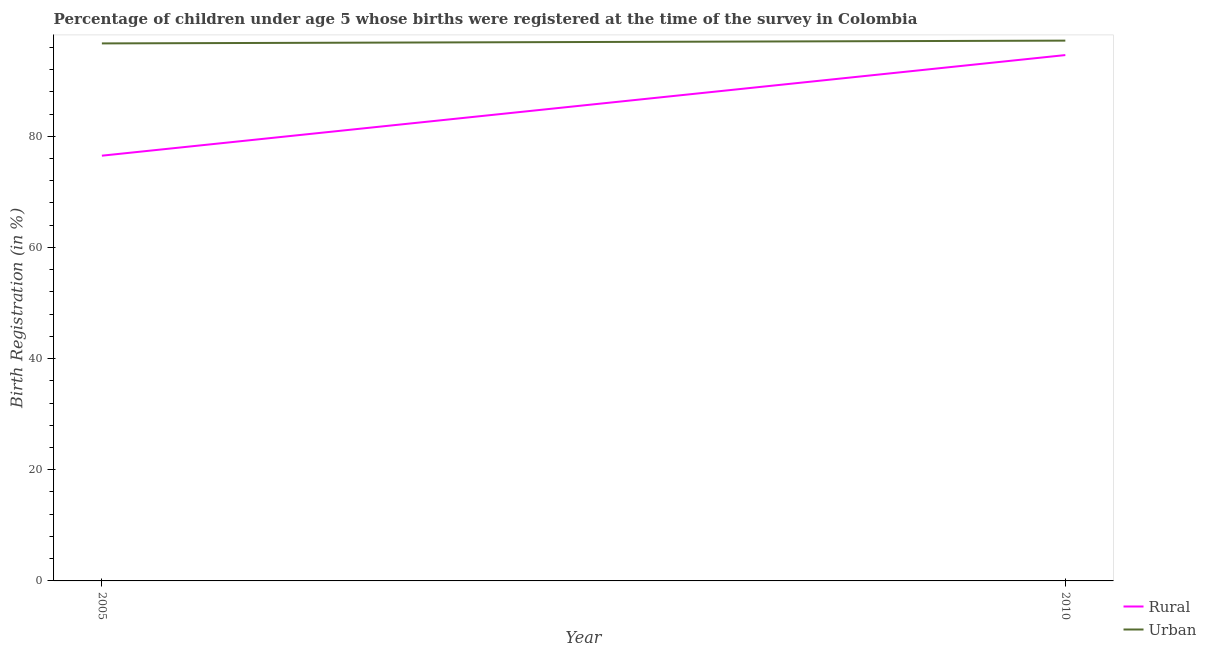How many different coloured lines are there?
Provide a succinct answer. 2. Does the line corresponding to urban birth registration intersect with the line corresponding to rural birth registration?
Give a very brief answer. No. Is the number of lines equal to the number of legend labels?
Keep it short and to the point. Yes. What is the rural birth registration in 2005?
Your response must be concise. 76.5. Across all years, what is the maximum urban birth registration?
Your answer should be very brief. 97.2. Across all years, what is the minimum urban birth registration?
Offer a terse response. 96.7. In which year was the urban birth registration maximum?
Provide a succinct answer. 2010. What is the total urban birth registration in the graph?
Keep it short and to the point. 193.9. What is the difference between the rural birth registration in 2005 and that in 2010?
Provide a succinct answer. -18.1. What is the difference between the urban birth registration in 2010 and the rural birth registration in 2005?
Your answer should be compact. 20.7. What is the average rural birth registration per year?
Make the answer very short. 85.55. In the year 2010, what is the difference between the urban birth registration and rural birth registration?
Provide a short and direct response. 2.6. What is the ratio of the urban birth registration in 2005 to that in 2010?
Keep it short and to the point. 0.99. Is the rural birth registration in 2005 less than that in 2010?
Make the answer very short. Yes. Is the urban birth registration strictly less than the rural birth registration over the years?
Provide a succinct answer. No. How many lines are there?
Offer a very short reply. 2. How many years are there in the graph?
Offer a very short reply. 2. What is the difference between two consecutive major ticks on the Y-axis?
Provide a short and direct response. 20. Are the values on the major ticks of Y-axis written in scientific E-notation?
Offer a terse response. No. Does the graph contain any zero values?
Your answer should be compact. No. What is the title of the graph?
Give a very brief answer. Percentage of children under age 5 whose births were registered at the time of the survey in Colombia. What is the label or title of the X-axis?
Your answer should be very brief. Year. What is the label or title of the Y-axis?
Make the answer very short. Birth Registration (in %). What is the Birth Registration (in %) in Rural in 2005?
Offer a very short reply. 76.5. What is the Birth Registration (in %) of Urban in 2005?
Provide a short and direct response. 96.7. What is the Birth Registration (in %) of Rural in 2010?
Your answer should be very brief. 94.6. What is the Birth Registration (in %) of Urban in 2010?
Keep it short and to the point. 97.2. Across all years, what is the maximum Birth Registration (in %) of Rural?
Ensure brevity in your answer.  94.6. Across all years, what is the maximum Birth Registration (in %) of Urban?
Make the answer very short. 97.2. Across all years, what is the minimum Birth Registration (in %) in Rural?
Keep it short and to the point. 76.5. Across all years, what is the minimum Birth Registration (in %) of Urban?
Provide a succinct answer. 96.7. What is the total Birth Registration (in %) of Rural in the graph?
Your answer should be very brief. 171.1. What is the total Birth Registration (in %) in Urban in the graph?
Make the answer very short. 193.9. What is the difference between the Birth Registration (in %) of Rural in 2005 and that in 2010?
Provide a short and direct response. -18.1. What is the difference between the Birth Registration (in %) in Rural in 2005 and the Birth Registration (in %) in Urban in 2010?
Offer a terse response. -20.7. What is the average Birth Registration (in %) in Rural per year?
Provide a succinct answer. 85.55. What is the average Birth Registration (in %) in Urban per year?
Provide a succinct answer. 96.95. In the year 2005, what is the difference between the Birth Registration (in %) in Rural and Birth Registration (in %) in Urban?
Offer a very short reply. -20.2. In the year 2010, what is the difference between the Birth Registration (in %) of Rural and Birth Registration (in %) of Urban?
Provide a succinct answer. -2.6. What is the ratio of the Birth Registration (in %) in Rural in 2005 to that in 2010?
Offer a terse response. 0.81. What is the difference between the highest and the lowest Birth Registration (in %) of Urban?
Make the answer very short. 0.5. 